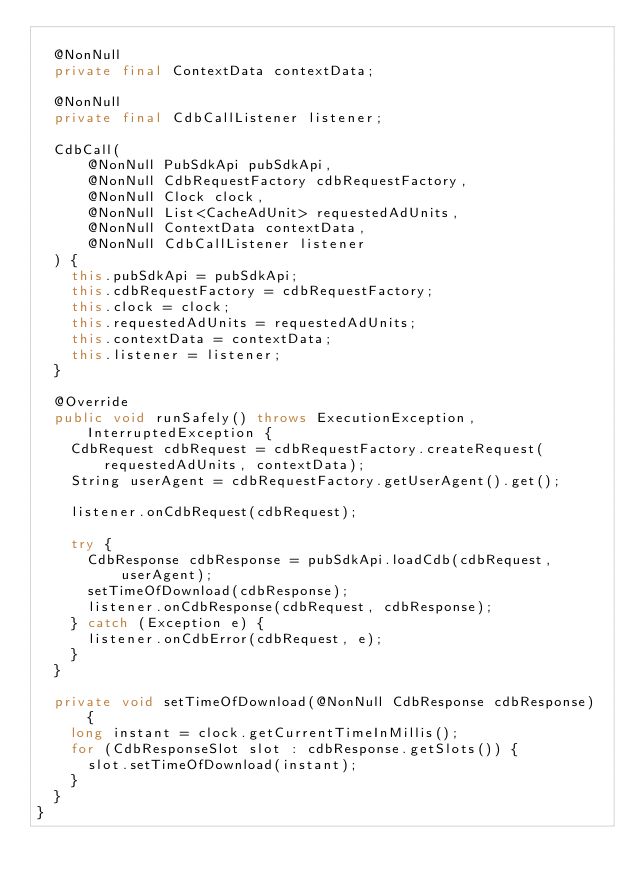Convert code to text. <code><loc_0><loc_0><loc_500><loc_500><_Java_>
  @NonNull
  private final ContextData contextData;

  @NonNull
  private final CdbCallListener listener;

  CdbCall(
      @NonNull PubSdkApi pubSdkApi,
      @NonNull CdbRequestFactory cdbRequestFactory,
      @NonNull Clock clock,
      @NonNull List<CacheAdUnit> requestedAdUnits,
      @NonNull ContextData contextData,
      @NonNull CdbCallListener listener
  ) {
    this.pubSdkApi = pubSdkApi;
    this.cdbRequestFactory = cdbRequestFactory;
    this.clock = clock;
    this.requestedAdUnits = requestedAdUnits;
    this.contextData = contextData;
    this.listener = listener;
  }

  @Override
  public void runSafely() throws ExecutionException, InterruptedException {
    CdbRequest cdbRequest = cdbRequestFactory.createRequest(requestedAdUnits, contextData);
    String userAgent = cdbRequestFactory.getUserAgent().get();

    listener.onCdbRequest(cdbRequest);

    try {
      CdbResponse cdbResponse = pubSdkApi.loadCdb(cdbRequest, userAgent);
      setTimeOfDownload(cdbResponse);
      listener.onCdbResponse(cdbRequest, cdbResponse);
    } catch (Exception e) {
      listener.onCdbError(cdbRequest, e);
    }
  }

  private void setTimeOfDownload(@NonNull CdbResponse cdbResponse) {
    long instant = clock.getCurrentTimeInMillis();
    for (CdbResponseSlot slot : cdbResponse.getSlots()) {
      slot.setTimeOfDownload(instant);
    }
  }
}
</code> 